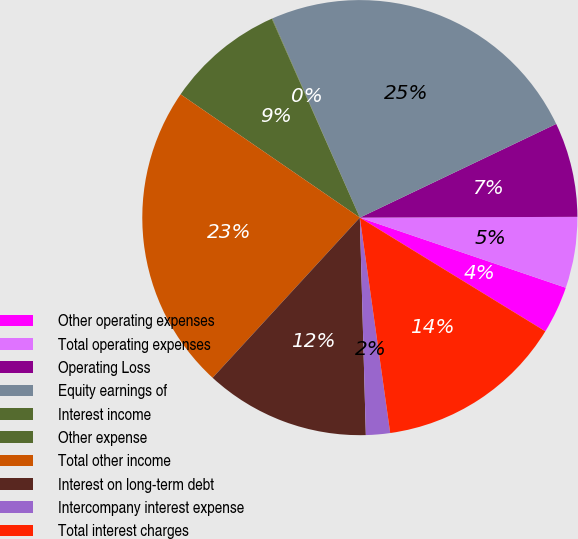<chart> <loc_0><loc_0><loc_500><loc_500><pie_chart><fcel>Other operating expenses<fcel>Total operating expenses<fcel>Operating Loss<fcel>Equity earnings of<fcel>Interest income<fcel>Other expense<fcel>Total other income<fcel>Interest on long-term debt<fcel>Intercompany interest expense<fcel>Total interest charges<nl><fcel>3.53%<fcel>5.28%<fcel>7.03%<fcel>24.51%<fcel>0.04%<fcel>8.78%<fcel>22.76%<fcel>12.27%<fcel>1.79%<fcel>14.02%<nl></chart> 